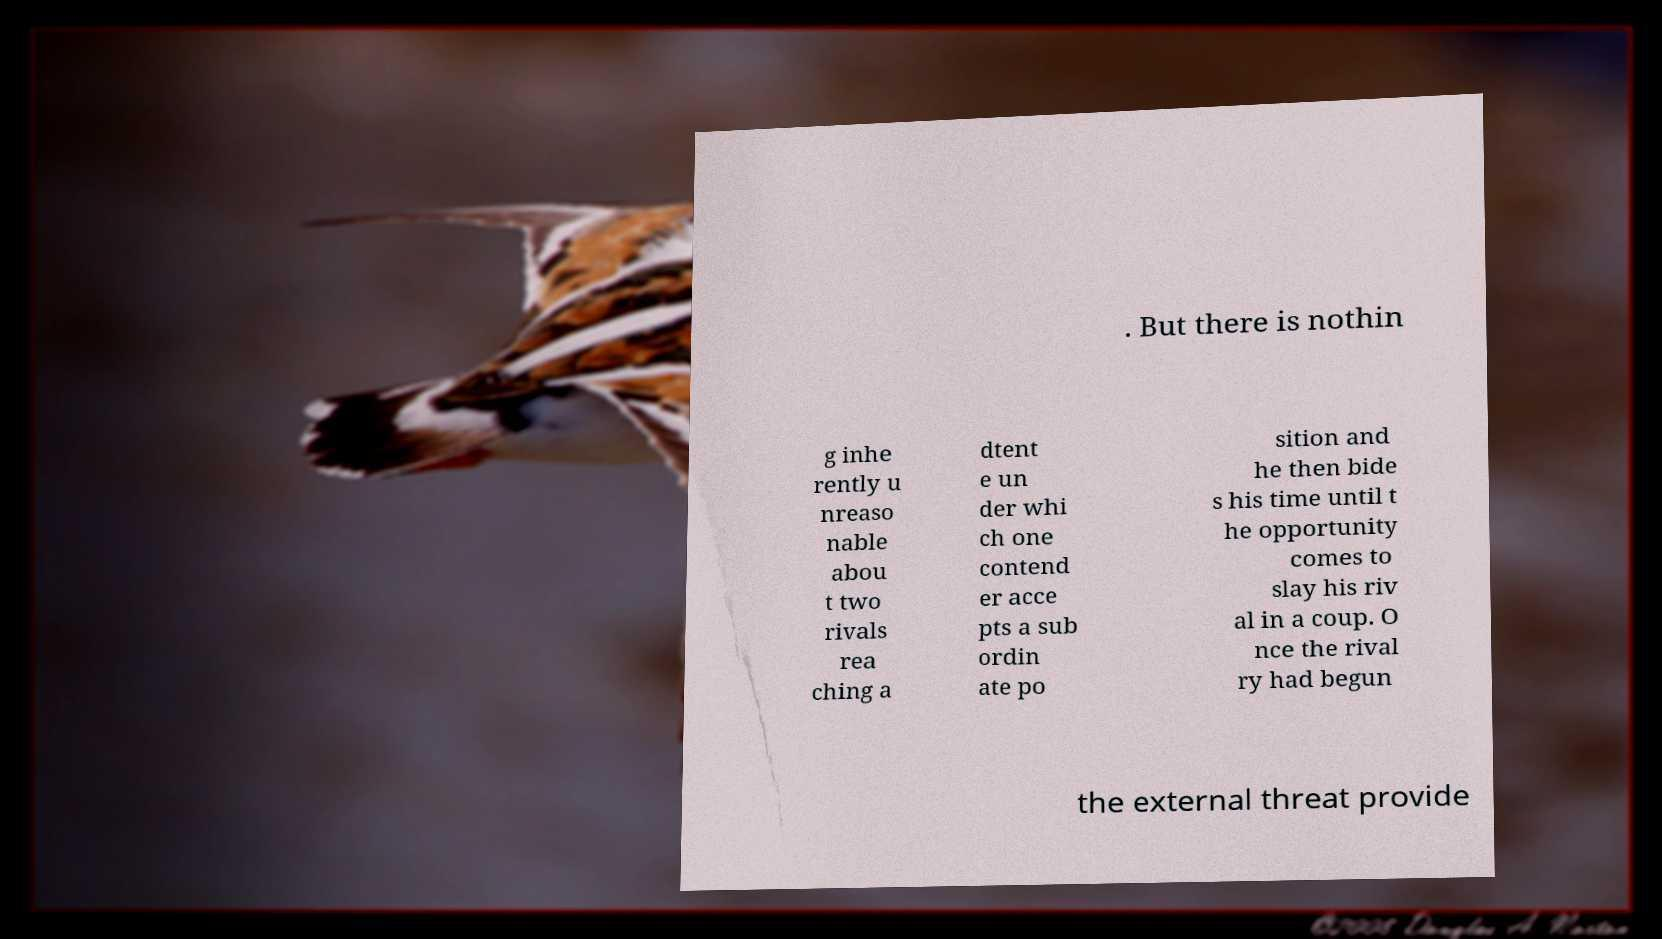Please read and relay the text visible in this image. What does it say? . But there is nothin g inhe rently u nreaso nable abou t two rivals rea ching a dtent e un der whi ch one contend er acce pts a sub ordin ate po sition and he then bide s his time until t he opportunity comes to slay his riv al in a coup. O nce the rival ry had begun the external threat provide 